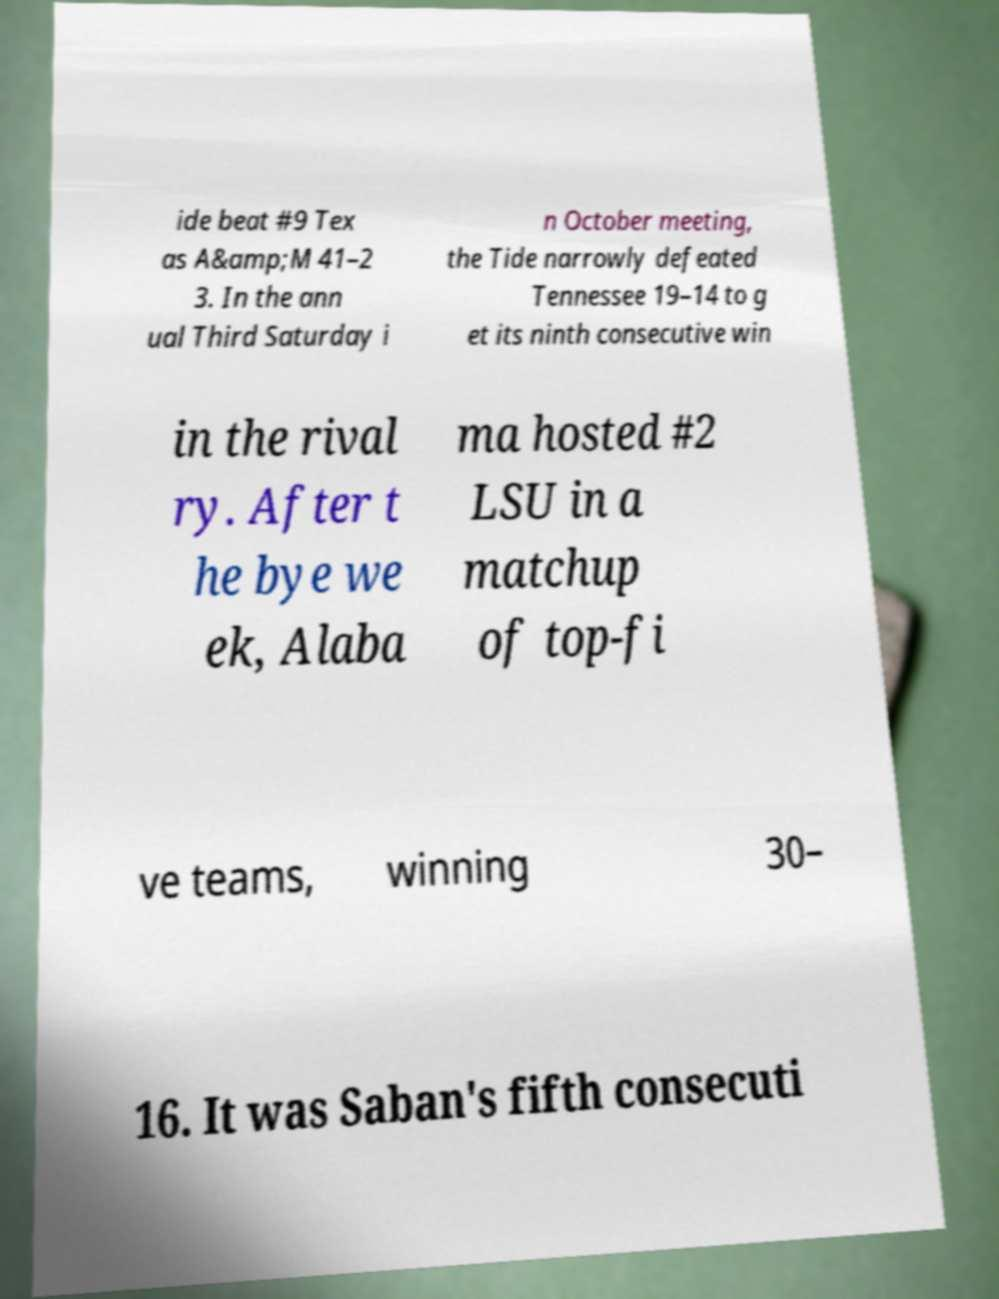What messages or text are displayed in this image? I need them in a readable, typed format. ide beat #9 Tex as A&amp;M 41–2 3. In the ann ual Third Saturday i n October meeting, the Tide narrowly defeated Tennessee 19–14 to g et its ninth consecutive win in the rival ry. After t he bye we ek, Alaba ma hosted #2 LSU in a matchup of top-fi ve teams, winning 30– 16. It was Saban's fifth consecuti 